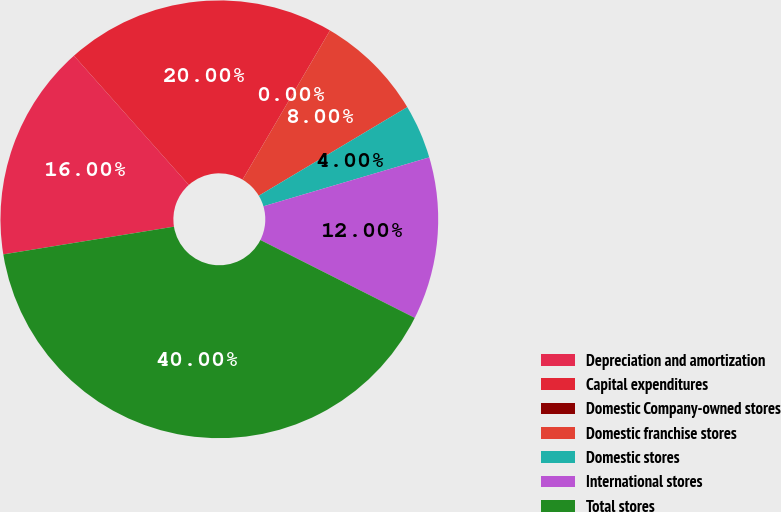Convert chart. <chart><loc_0><loc_0><loc_500><loc_500><pie_chart><fcel>Depreciation and amortization<fcel>Capital expenditures<fcel>Domestic Company-owned stores<fcel>Domestic franchise stores<fcel>Domestic stores<fcel>International stores<fcel>Total stores<nl><fcel>16.0%<fcel>20.0%<fcel>0.0%<fcel>8.0%<fcel>4.0%<fcel>12.0%<fcel>40.0%<nl></chart> 